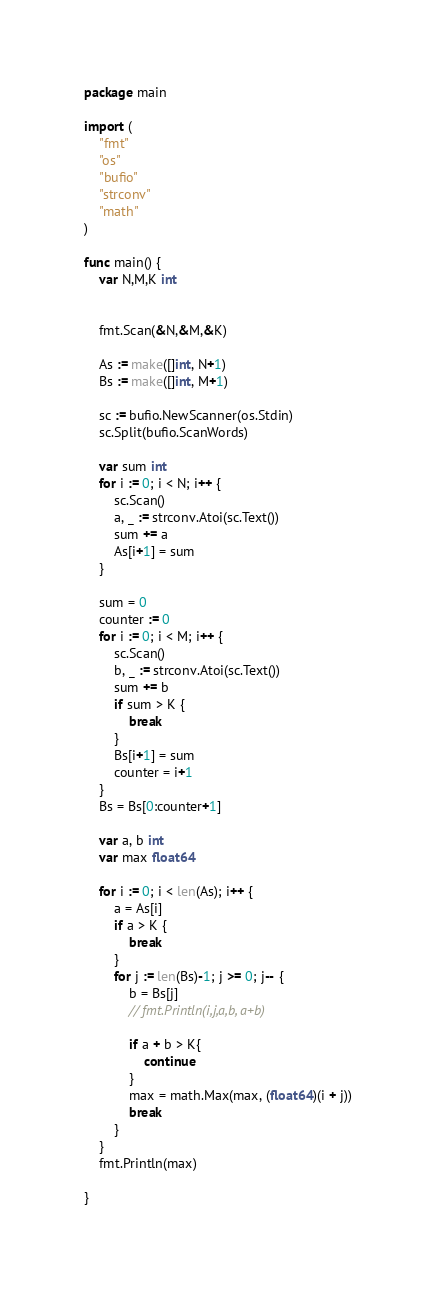Convert code to text. <code><loc_0><loc_0><loc_500><loc_500><_Go_>package main

import (
	"fmt"
	"os"
	"bufio"
	"strconv"
	"math"
)

func main() {
	var N,M,K int

	
	fmt.Scan(&N,&M,&K)

	As := make([]int, N+1)
	Bs := make([]int, M+1)

	sc := bufio.NewScanner(os.Stdin)
	sc.Split(bufio.ScanWords)

	var sum int
	for i := 0; i < N; i++ {
		sc.Scan()
		a, _ := strconv.Atoi(sc.Text())
		sum += a
		As[i+1] = sum		
	}

	sum = 0
	counter := 0
	for i := 0; i < M; i++ {
		sc.Scan()
		b, _ := strconv.Atoi(sc.Text())
		sum += b
		if sum > K {
			break
		}
		Bs[i+1] = sum
		counter = i+1
	}
	Bs = Bs[0:counter+1]

	var a, b int
	var max float64

	for i := 0; i < len(As); i++ {
		a = As[i]
		if a > K {
			break
		}
		for j := len(Bs)-1; j >= 0; j-- {
			b = Bs[j]
			// fmt.Println(i,j,a,b, a+b)

			if a + b > K{
				continue
			}
			max = math.Max(max, (float64)(i + j))
			break
		}
	}
	fmt.Println(max)

}

</code> 